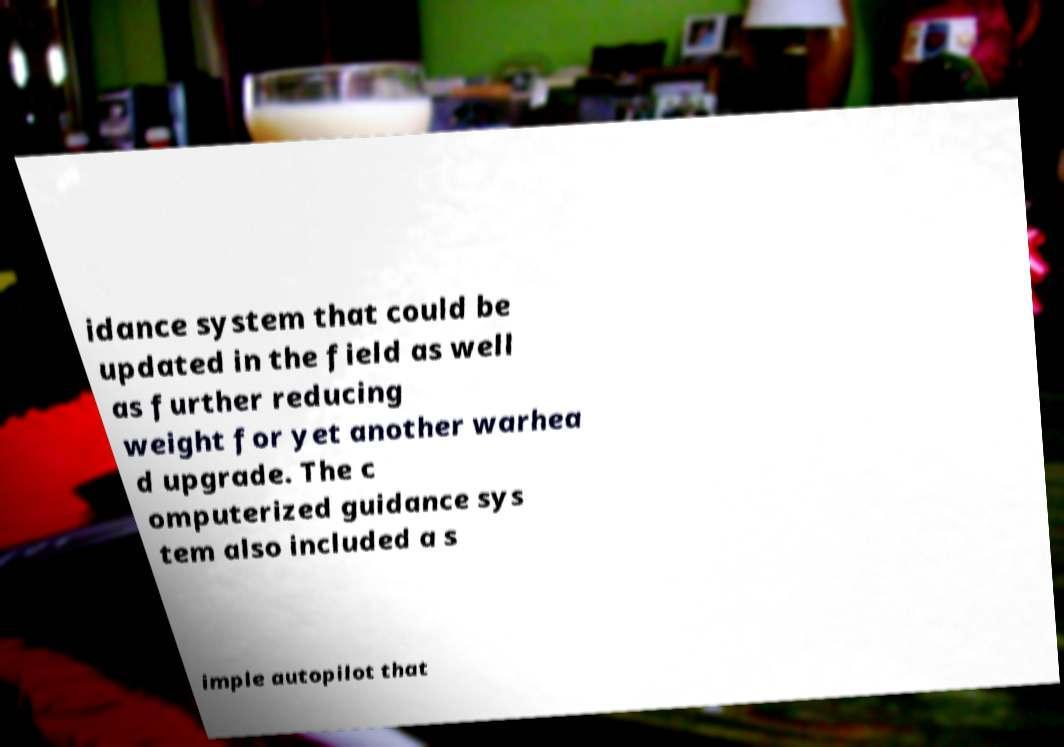Can you accurately transcribe the text from the provided image for me? idance system that could be updated in the field as well as further reducing weight for yet another warhea d upgrade. The c omputerized guidance sys tem also included a s imple autopilot that 